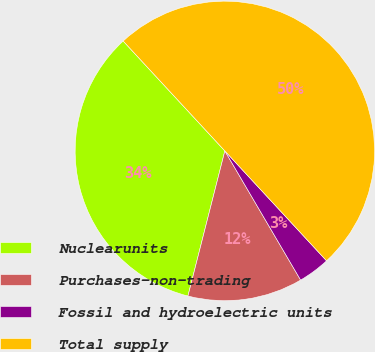Convert chart. <chart><loc_0><loc_0><loc_500><loc_500><pie_chart><fcel>Nuclearunits<fcel>Purchases-non-trading<fcel>Fossil and hydroelectric units<fcel>Total supply<nl><fcel>34.15%<fcel>12.41%<fcel>3.44%<fcel>50.0%<nl></chart> 